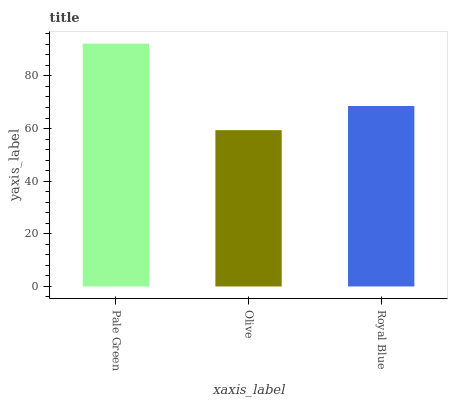Is Royal Blue the minimum?
Answer yes or no. No. Is Royal Blue the maximum?
Answer yes or no. No. Is Royal Blue greater than Olive?
Answer yes or no. Yes. Is Olive less than Royal Blue?
Answer yes or no. Yes. Is Olive greater than Royal Blue?
Answer yes or no. No. Is Royal Blue less than Olive?
Answer yes or no. No. Is Royal Blue the high median?
Answer yes or no. Yes. Is Royal Blue the low median?
Answer yes or no. Yes. Is Olive the high median?
Answer yes or no. No. Is Pale Green the low median?
Answer yes or no. No. 